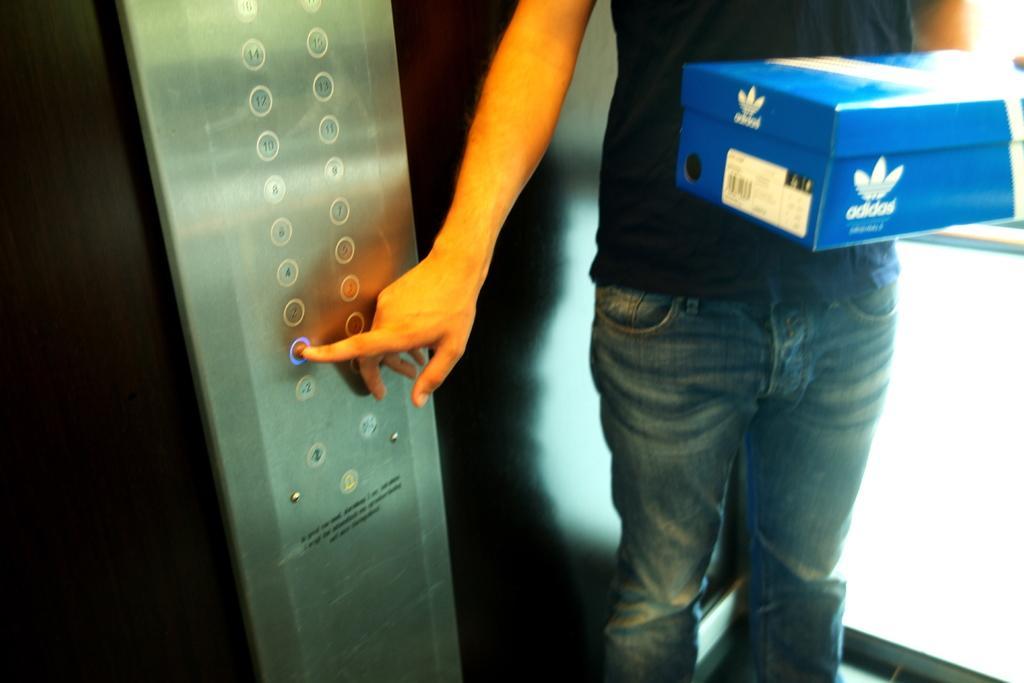In one or two sentences, can you explain what this image depicts? In this picture we can see a person in the black t shirt is holding an "Adidas box". It looks like the person is standing in the elevator. On the left side of the person there are elevator push buttons. 